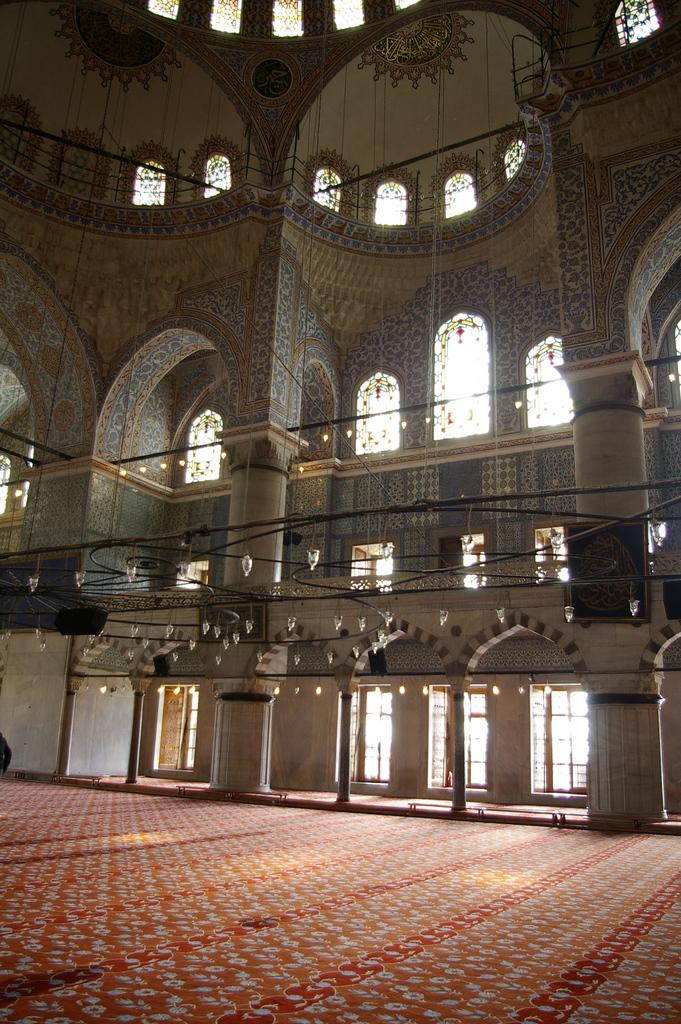What type of location is shown in the image? The image depicts the inside of a building. What can be seen running along the walls or ceiling in the image? There are cables visible in the image. What can be seen providing illumination in the image? There are lights visible in the image. What type of authority figure can be seen in the image? There is no authority figure present in the image; it only shows the inside of a building with cables and lights. 